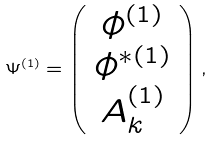<formula> <loc_0><loc_0><loc_500><loc_500>\Psi ^ { ( 1 ) } = \left ( \begin{array} { c } \phi ^ { ( 1 ) } \\ \phi ^ { \ast ( 1 ) } \\ A _ { k } ^ { ( 1 ) } \end{array} \right ) ,</formula> 